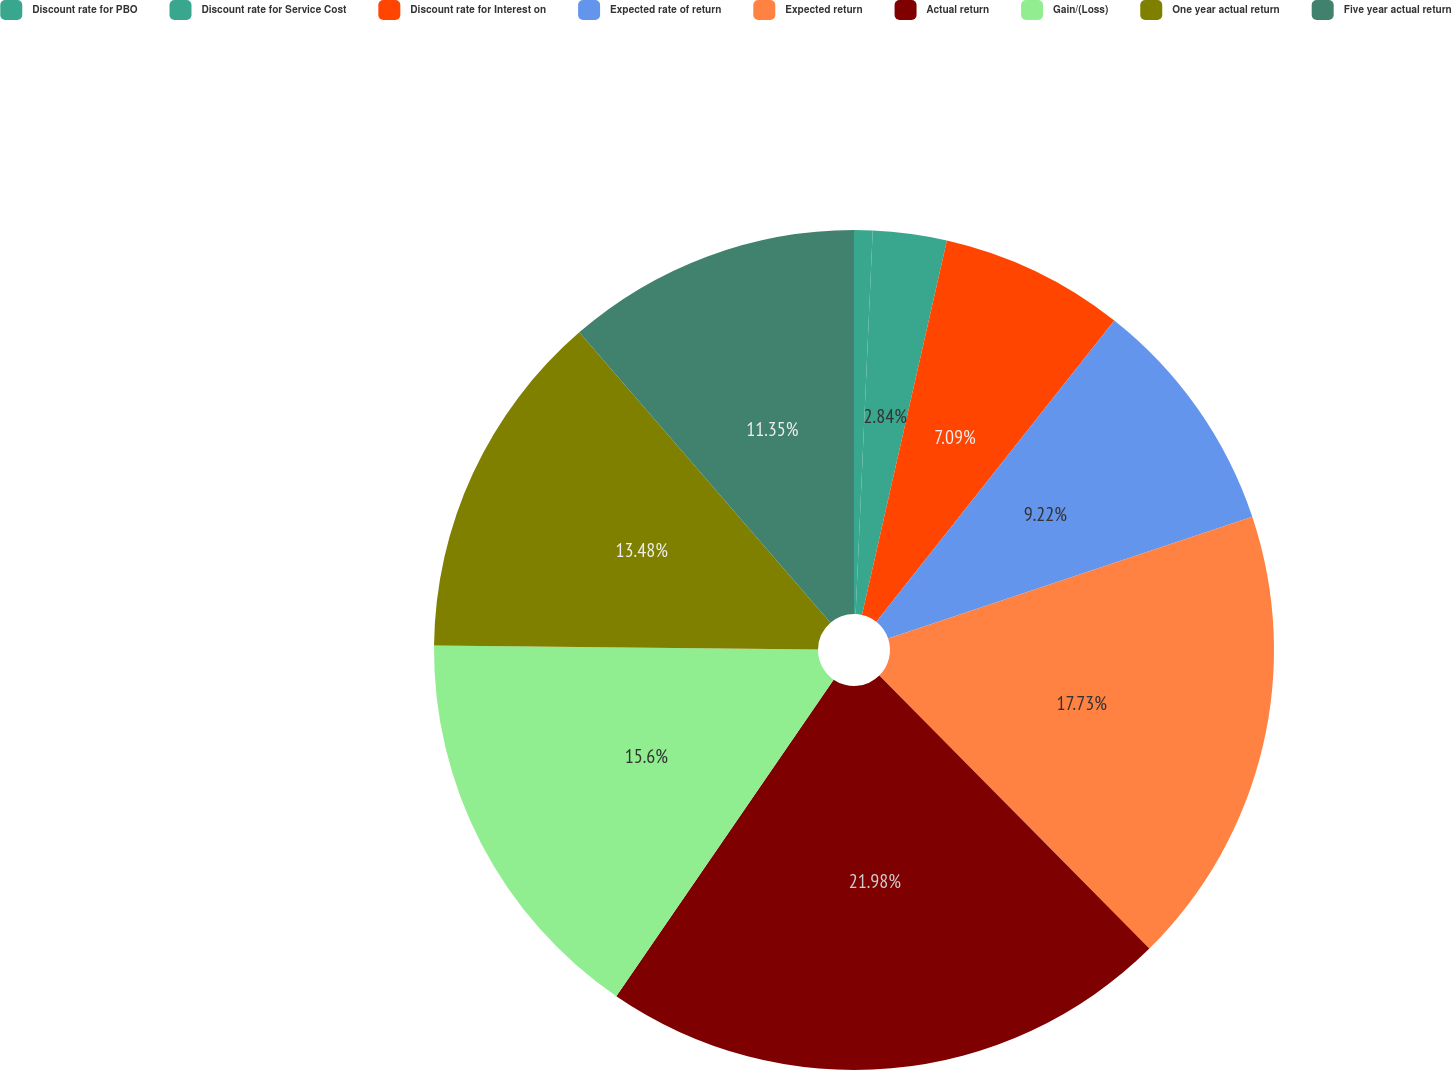Convert chart. <chart><loc_0><loc_0><loc_500><loc_500><pie_chart><fcel>Discount rate for PBO<fcel>Discount rate for Service Cost<fcel>Discount rate for Interest on<fcel>Expected rate of return<fcel>Expected return<fcel>Actual return<fcel>Gain/(Loss)<fcel>One year actual return<fcel>Five year actual return<nl><fcel>0.71%<fcel>2.84%<fcel>7.09%<fcel>9.22%<fcel>17.73%<fcel>21.99%<fcel>15.6%<fcel>13.48%<fcel>11.35%<nl></chart> 